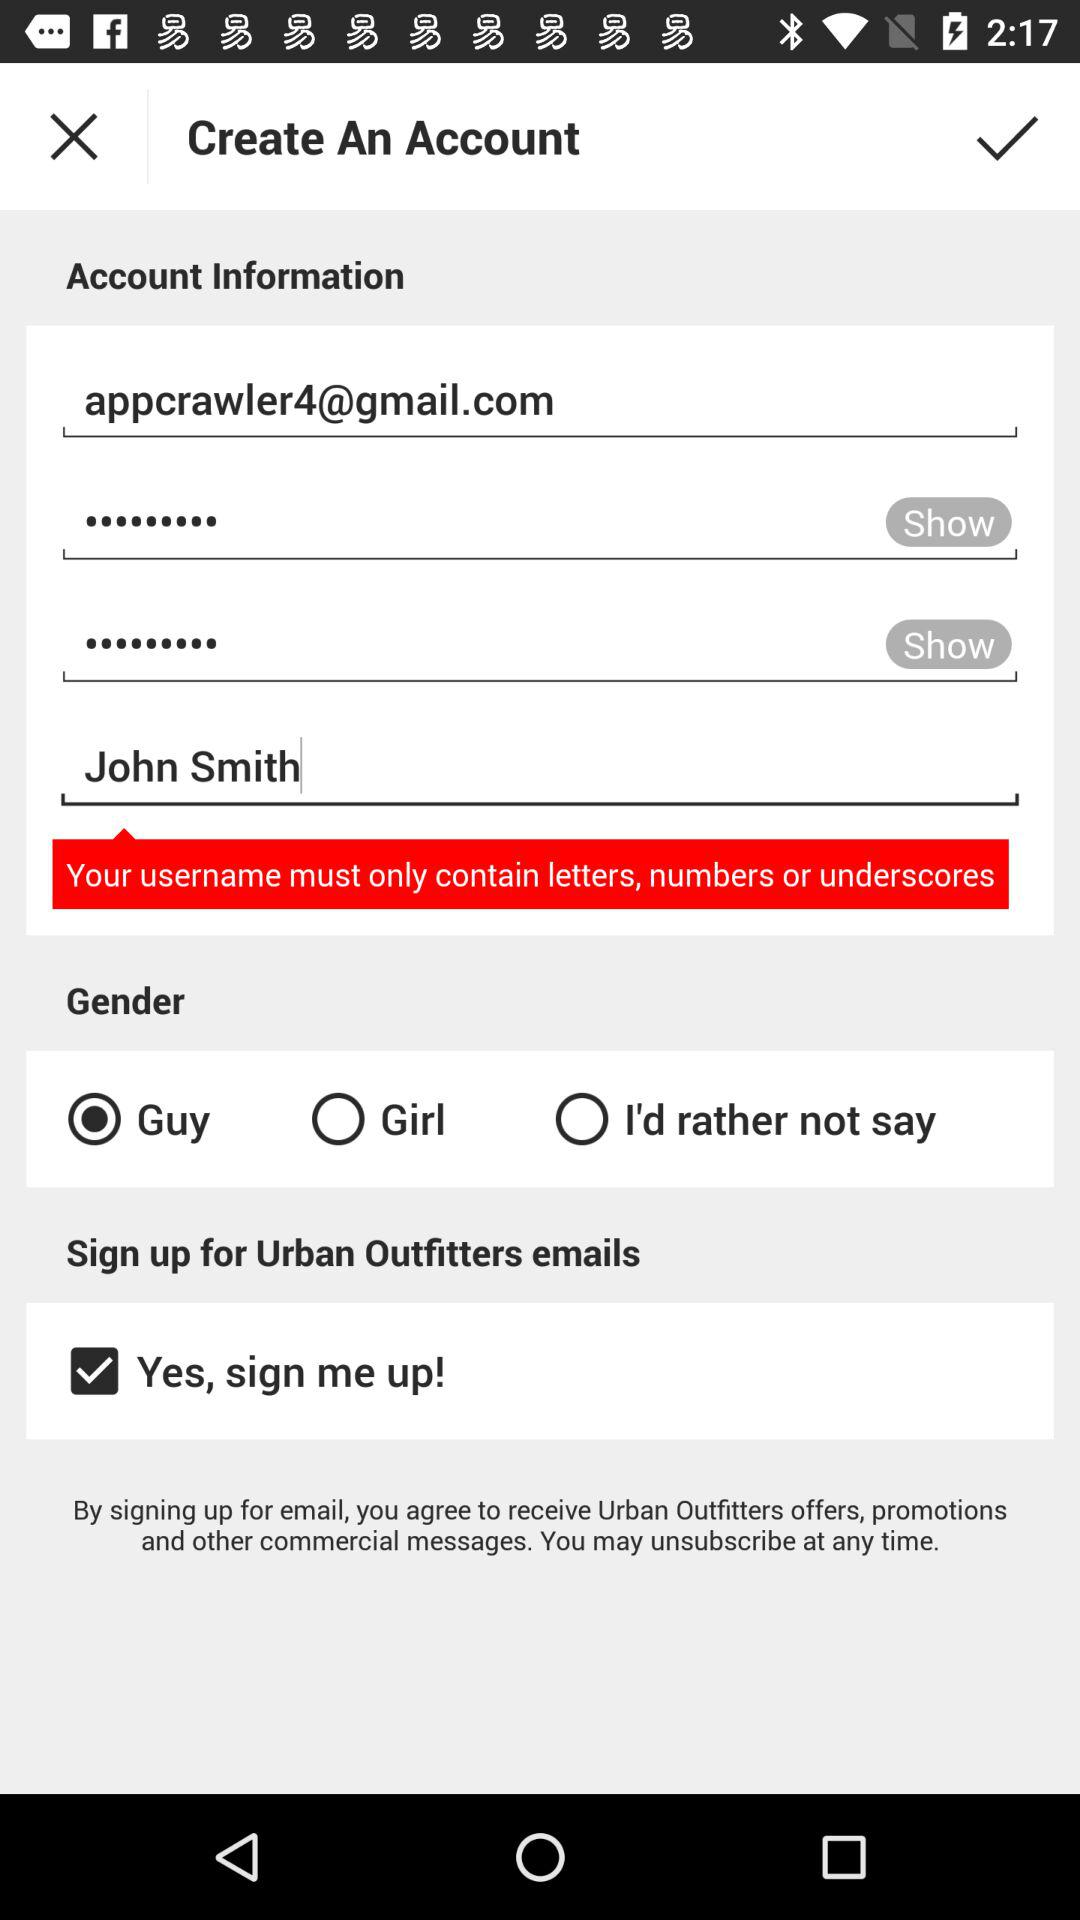What is the chosen gender of the user? The user is a guy. 